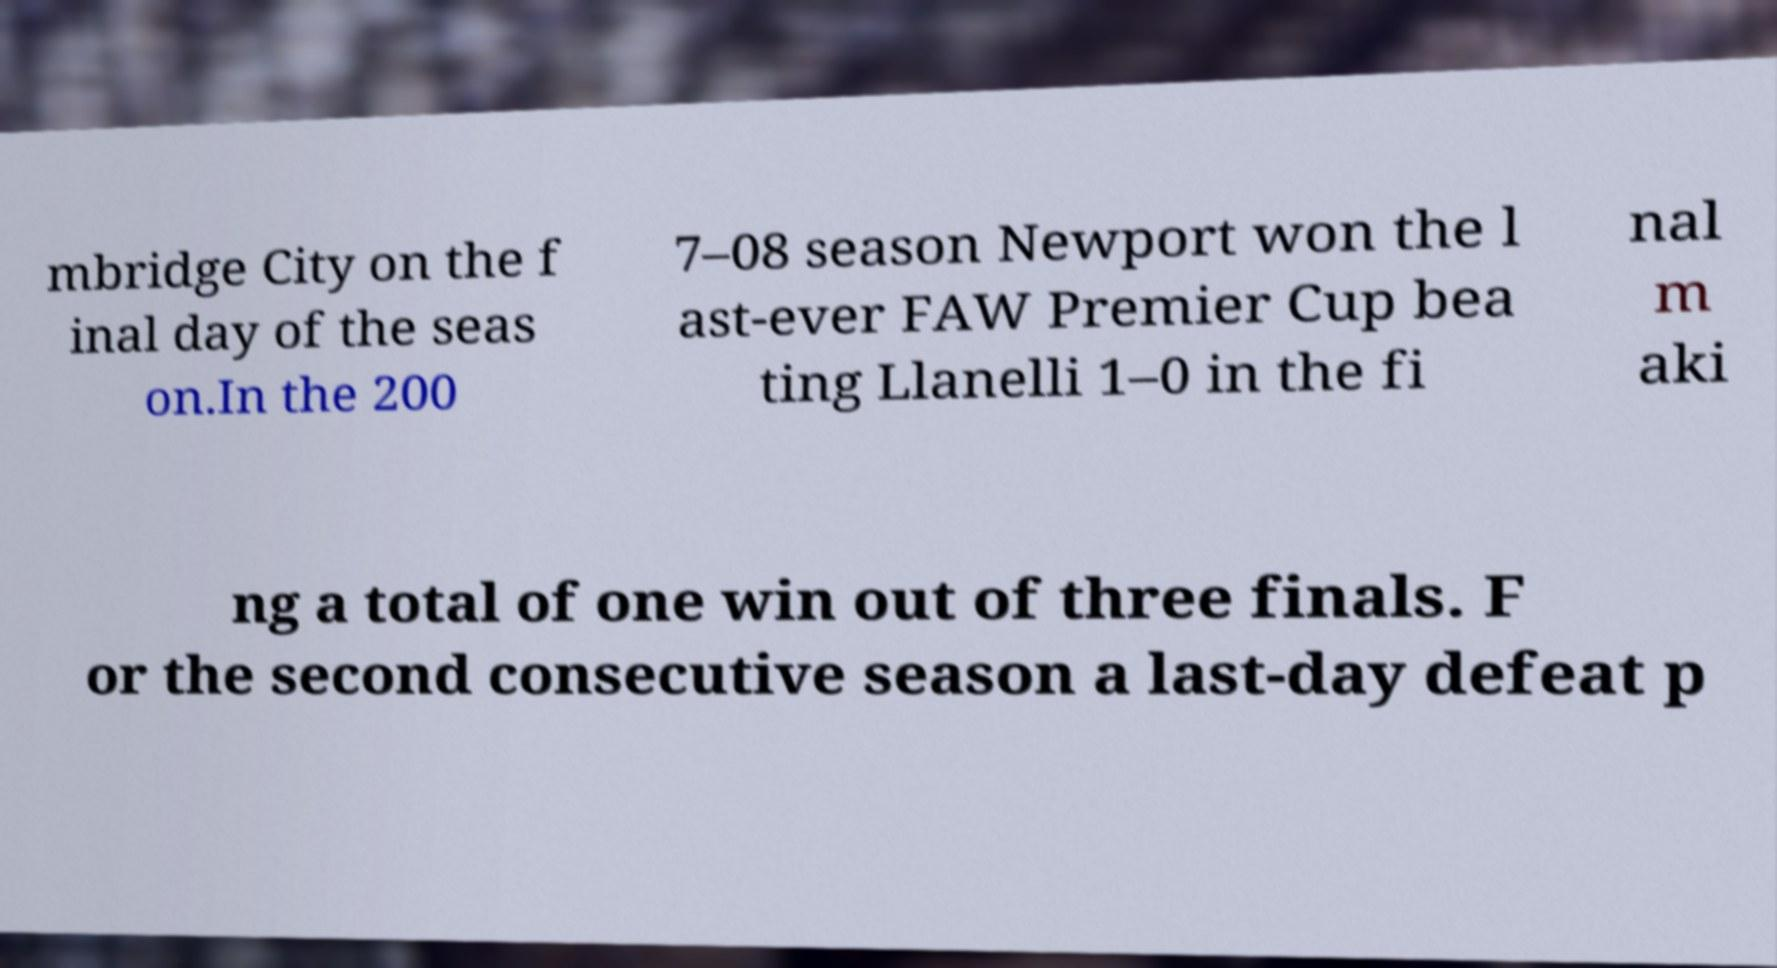There's text embedded in this image that I need extracted. Can you transcribe it verbatim? mbridge City on the f inal day of the seas on.In the 200 7–08 season Newport won the l ast-ever FAW Premier Cup bea ting Llanelli 1–0 in the fi nal m aki ng a total of one win out of three finals. F or the second consecutive season a last-day defeat p 